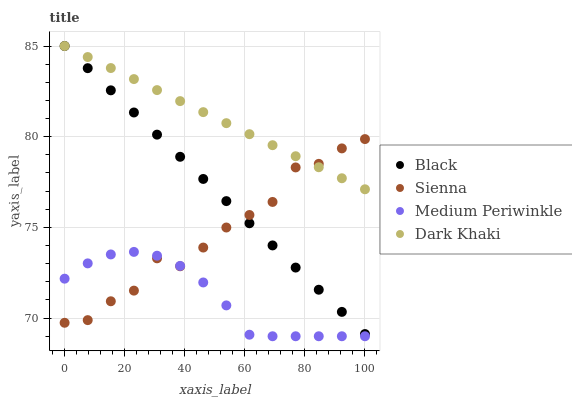Does Medium Periwinkle have the minimum area under the curve?
Answer yes or no. Yes. Does Dark Khaki have the maximum area under the curve?
Answer yes or no. Yes. Does Black have the minimum area under the curve?
Answer yes or no. No. Does Black have the maximum area under the curve?
Answer yes or no. No. Is Black the smoothest?
Answer yes or no. Yes. Is Sienna the roughest?
Answer yes or no. Yes. Is Medium Periwinkle the smoothest?
Answer yes or no. No. Is Medium Periwinkle the roughest?
Answer yes or no. No. Does Medium Periwinkle have the lowest value?
Answer yes or no. Yes. Does Black have the lowest value?
Answer yes or no. No. Does Dark Khaki have the highest value?
Answer yes or no. Yes. Does Medium Periwinkle have the highest value?
Answer yes or no. No. Is Medium Periwinkle less than Dark Khaki?
Answer yes or no. Yes. Is Black greater than Medium Periwinkle?
Answer yes or no. Yes. Does Black intersect Sienna?
Answer yes or no. Yes. Is Black less than Sienna?
Answer yes or no. No. Is Black greater than Sienna?
Answer yes or no. No. Does Medium Periwinkle intersect Dark Khaki?
Answer yes or no. No. 